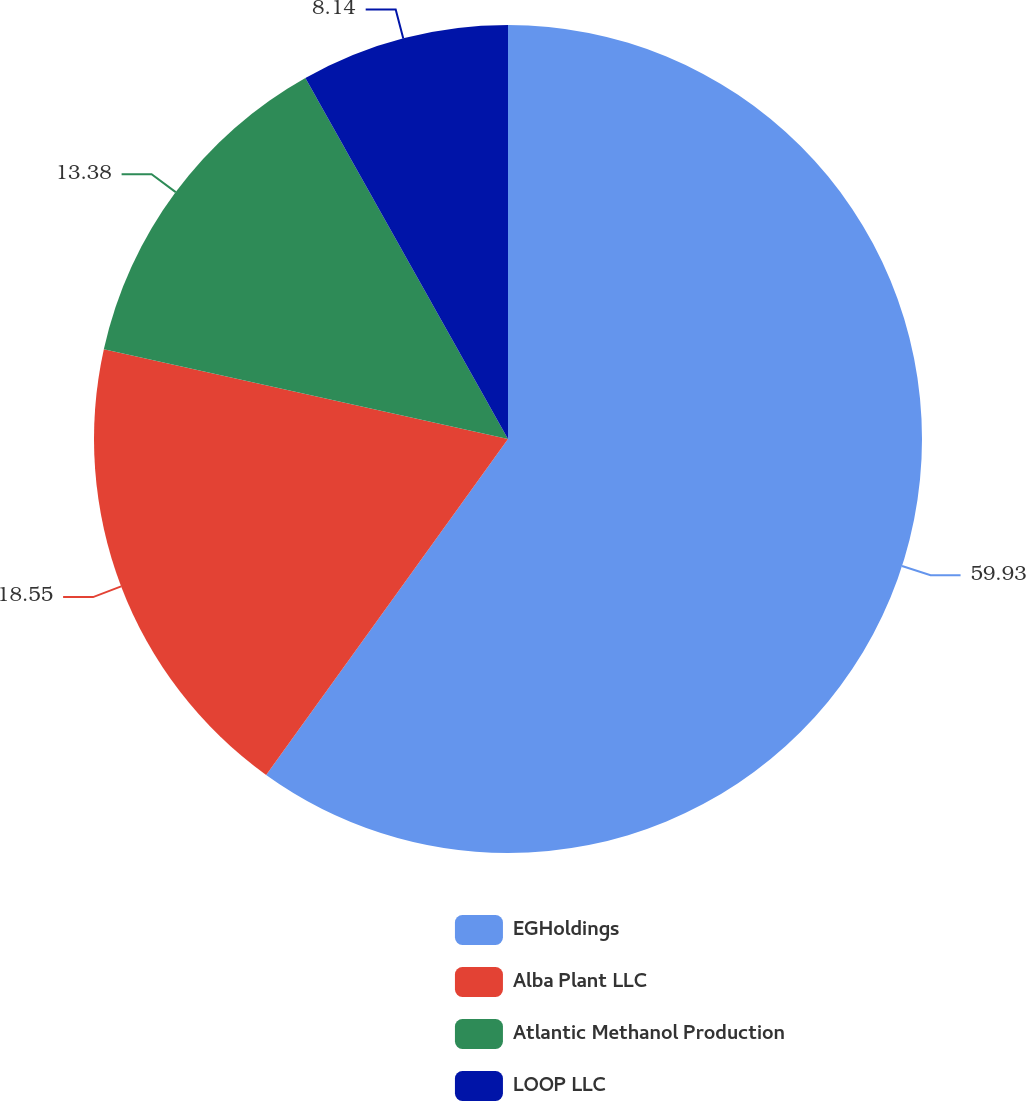Convert chart. <chart><loc_0><loc_0><loc_500><loc_500><pie_chart><fcel>EGHoldings<fcel>Alba Plant LLC<fcel>Atlantic Methanol Production<fcel>LOOP LLC<nl><fcel>59.93%<fcel>18.55%<fcel>13.38%<fcel>8.14%<nl></chart> 